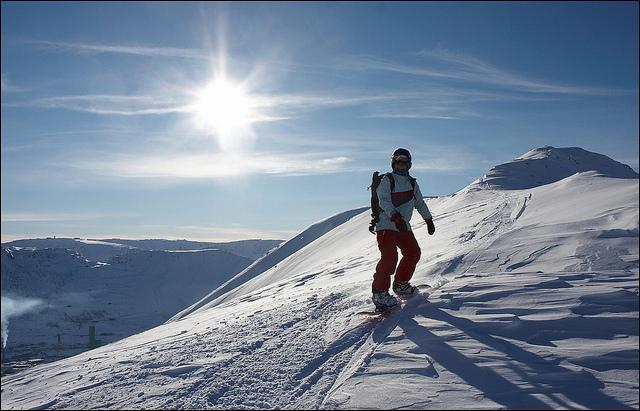Which direction will this person most likely go next? down 